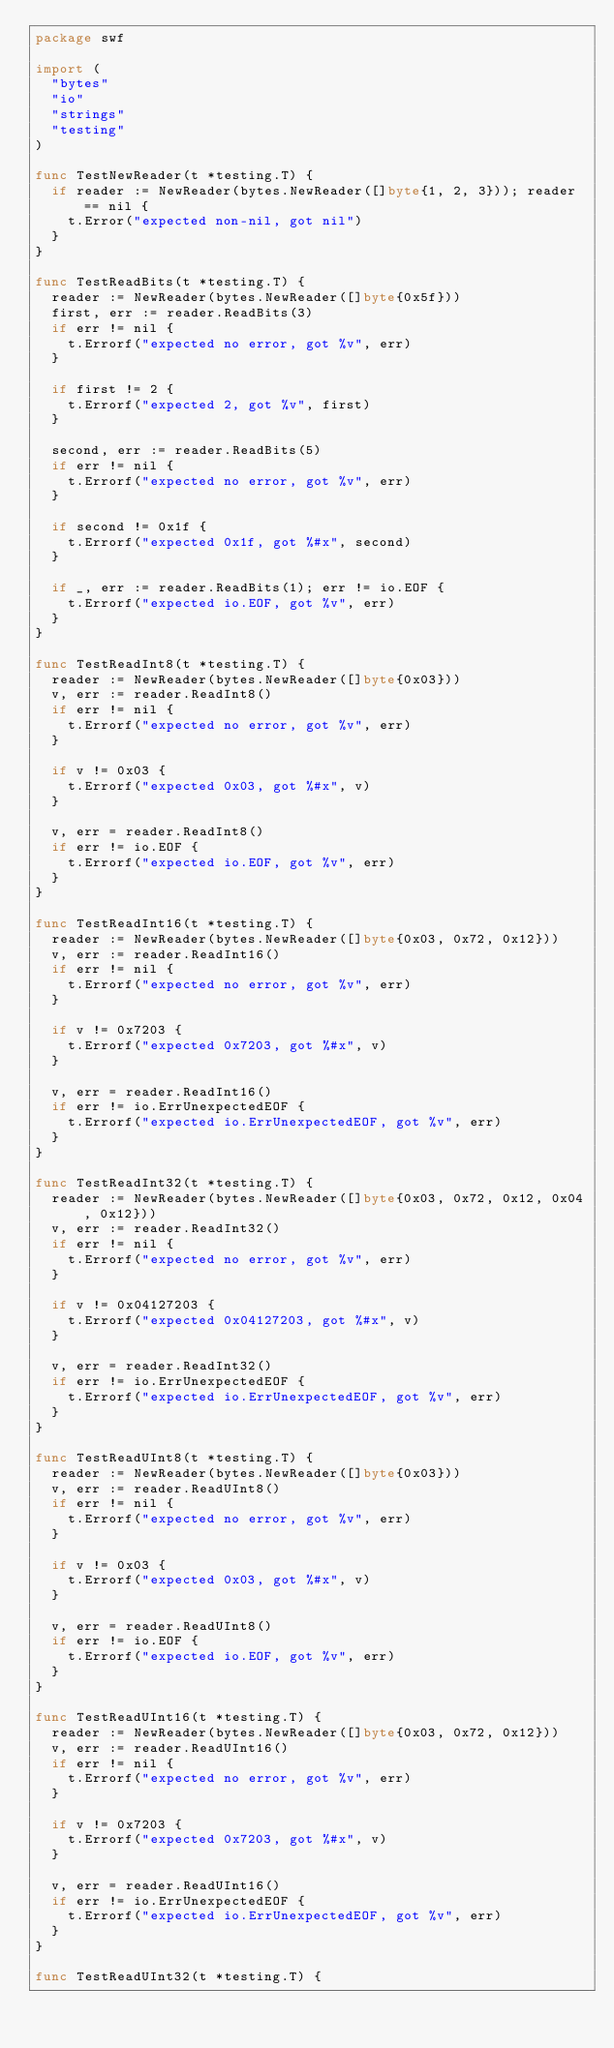<code> <loc_0><loc_0><loc_500><loc_500><_Go_>package swf

import (
	"bytes"
	"io"
	"strings"
	"testing"
)

func TestNewReader(t *testing.T) {
	if reader := NewReader(bytes.NewReader([]byte{1, 2, 3})); reader == nil {
		t.Error("expected non-nil, got nil")
	}
}

func TestReadBits(t *testing.T) {
	reader := NewReader(bytes.NewReader([]byte{0x5f}))
	first, err := reader.ReadBits(3)
	if err != nil {
		t.Errorf("expected no error, got %v", err)
	}

	if first != 2 {
		t.Errorf("expected 2, got %v", first)
	}

	second, err := reader.ReadBits(5)
	if err != nil {
		t.Errorf("expected no error, got %v", err)
	}

	if second != 0x1f {
		t.Errorf("expected 0x1f, got %#x", second)
	}

	if _, err := reader.ReadBits(1); err != io.EOF {
		t.Errorf("expected io.EOF, got %v", err)
	}
}

func TestReadInt8(t *testing.T) {
	reader := NewReader(bytes.NewReader([]byte{0x03}))
	v, err := reader.ReadInt8()
	if err != nil {
		t.Errorf("expected no error, got %v", err)
	}

	if v != 0x03 {
		t.Errorf("expected 0x03, got %#x", v)
	}

	v, err = reader.ReadInt8()
	if err != io.EOF {
		t.Errorf("expected io.EOF, got %v", err)
	}
}

func TestReadInt16(t *testing.T) {
	reader := NewReader(bytes.NewReader([]byte{0x03, 0x72, 0x12}))
	v, err := reader.ReadInt16()
	if err != nil {
		t.Errorf("expected no error, got %v", err)
	}

	if v != 0x7203 {
		t.Errorf("expected 0x7203, got %#x", v)
	}

	v, err = reader.ReadInt16()
	if err != io.ErrUnexpectedEOF {
		t.Errorf("expected io.ErrUnexpectedEOF, got %v", err)
	}
}

func TestReadInt32(t *testing.T) {
	reader := NewReader(bytes.NewReader([]byte{0x03, 0x72, 0x12, 0x04, 0x12}))
	v, err := reader.ReadInt32()
	if err != nil {
		t.Errorf("expected no error, got %v", err)
	}

	if v != 0x04127203 {
		t.Errorf("expected 0x04127203, got %#x", v)
	}

	v, err = reader.ReadInt32()
	if err != io.ErrUnexpectedEOF {
		t.Errorf("expected io.ErrUnexpectedEOF, got %v", err)
	}
}

func TestReadUInt8(t *testing.T) {
	reader := NewReader(bytes.NewReader([]byte{0x03}))
	v, err := reader.ReadUInt8()
	if err != nil {
		t.Errorf("expected no error, got %v", err)
	}

	if v != 0x03 {
		t.Errorf("expected 0x03, got %#x", v)
	}

	v, err = reader.ReadUInt8()
	if err != io.EOF {
		t.Errorf("expected io.EOF, got %v", err)
	}
}

func TestReadUInt16(t *testing.T) {
	reader := NewReader(bytes.NewReader([]byte{0x03, 0x72, 0x12}))
	v, err := reader.ReadUInt16()
	if err != nil {
		t.Errorf("expected no error, got %v", err)
	}

	if v != 0x7203 {
		t.Errorf("expected 0x7203, got %#x", v)
	}

	v, err = reader.ReadUInt16()
	if err != io.ErrUnexpectedEOF {
		t.Errorf("expected io.ErrUnexpectedEOF, got %v", err)
	}
}

func TestReadUInt32(t *testing.T) {</code> 